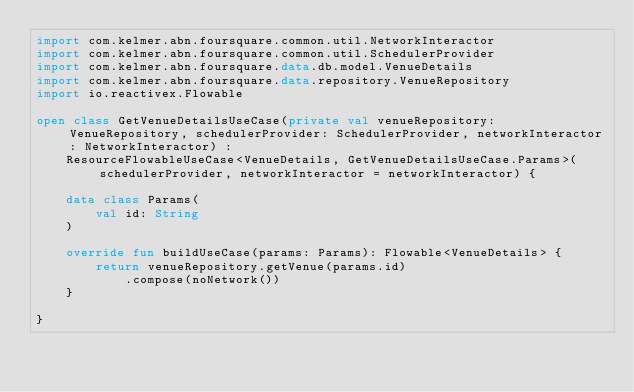Convert code to text. <code><loc_0><loc_0><loc_500><loc_500><_Kotlin_>import com.kelmer.abn.foursquare.common.util.NetworkInteractor
import com.kelmer.abn.foursquare.common.util.SchedulerProvider
import com.kelmer.abn.foursquare.data.db.model.VenueDetails
import com.kelmer.abn.foursquare.data.repository.VenueRepository
import io.reactivex.Flowable

open class GetVenueDetailsUseCase(private val venueRepository: VenueRepository, schedulerProvider: SchedulerProvider, networkInteractor: NetworkInteractor) :
    ResourceFlowableUseCase<VenueDetails, GetVenueDetailsUseCase.Params>(schedulerProvider, networkInteractor = networkInteractor) {

    data class Params(
        val id: String
    )

    override fun buildUseCase(params: Params): Flowable<VenueDetails> {
        return venueRepository.getVenue(params.id)
            .compose(noNetwork())
    }

}</code> 